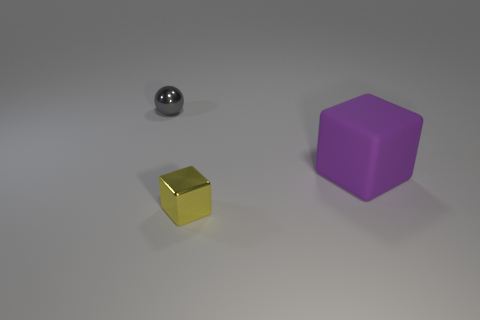Add 2 large metallic spheres. How many objects exist? 5 Subtract all cubes. How many objects are left? 1 Add 1 small gray things. How many small gray things exist? 2 Subtract 0 yellow spheres. How many objects are left? 3 Subtract all large metallic cylinders. Subtract all small yellow metallic cubes. How many objects are left? 2 Add 1 tiny yellow shiny cubes. How many tiny yellow shiny cubes are left? 2 